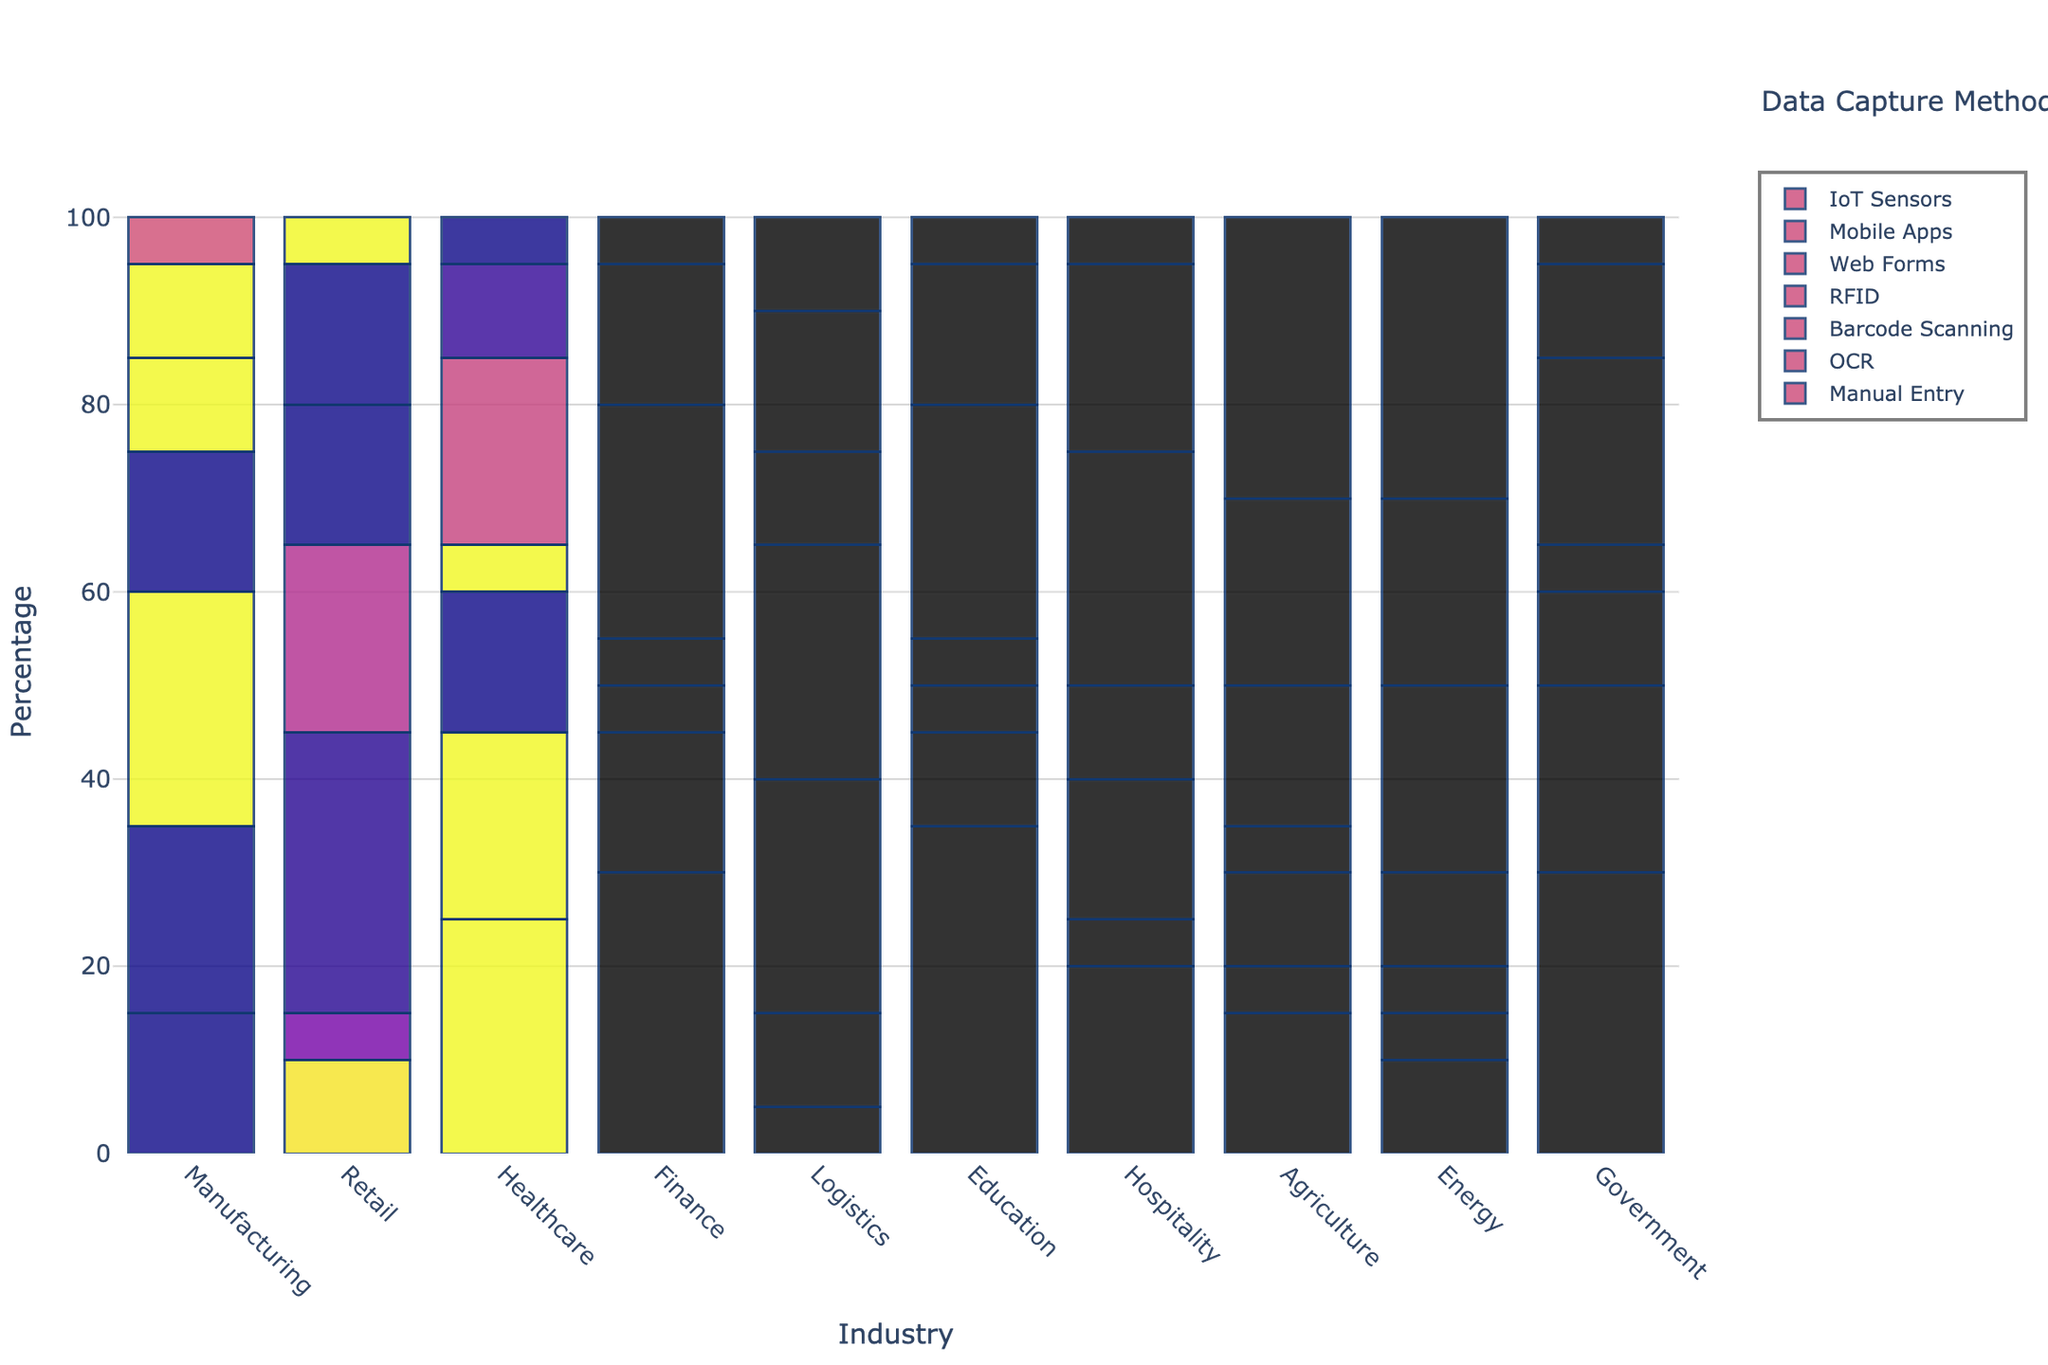Which industry uses Manual Entry the most? The bar for Education in Manual Entry is the highest compared to other industries. Therefore, Education uses Manual Entry the most.
Answer: Education Which data capture method is most utilized in the Retail industry? The bar for Barcode Scanning in the Retail industry is the highest among all methods, indicating Barcode Scanning is the most utilized method.
Answer: Barcode Scanning Compare Web Forms usage between Healthcare and Finance industries, which one uses it more? The height of the bar for Web Forms is higher in Finance compared to Healthcare, indicating Finance uses Web Forms more.
Answer: Finance Which two industries use IoT Sensors the most? The bars for IoT Sensors are highest for Agriculture and Energy. Thus, these two industries use IoT Sensors the most.
Answer: Agriculture and Energy What is the combined percentage of OCR and RFID usage in the Logistics industry? The bar heights for OCR and RFID in Logistics are 10 and 25 respectively. Adding them, 10 + 25 = 35.
Answer: 35 Between Manual Entry and Mobile Apps, which method has a lower usage in the Healthcare industry? By observing the bar heights, the bar for Mobile Apps is lower than that for Manual Entry in Healthcare.
Answer: Mobile Apps Is the total usage of Web Forms below 30% in the Manufacturing industry? The height of the bar for Web Forms in Manufacturing is 10, which is less than 30.
Answer: Yes What method has nearly equal usage across all industries? The bars for RFID are relatively similar across all industries.
Answer: RFID Which industry shows the least reliance on Barcode Scanning? The bar for Barcode Scanning is lowest in the Education industry compared to all other industries.
Answer: Education What is the difference in the usage of Mobile Apps between Agriculture and Energy industries? The bar for Mobile Apps is 20 in both Agriculture and Energy, indicating there’s no difference.
Answer: 0 